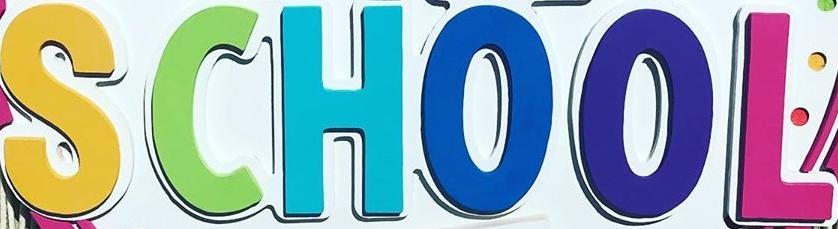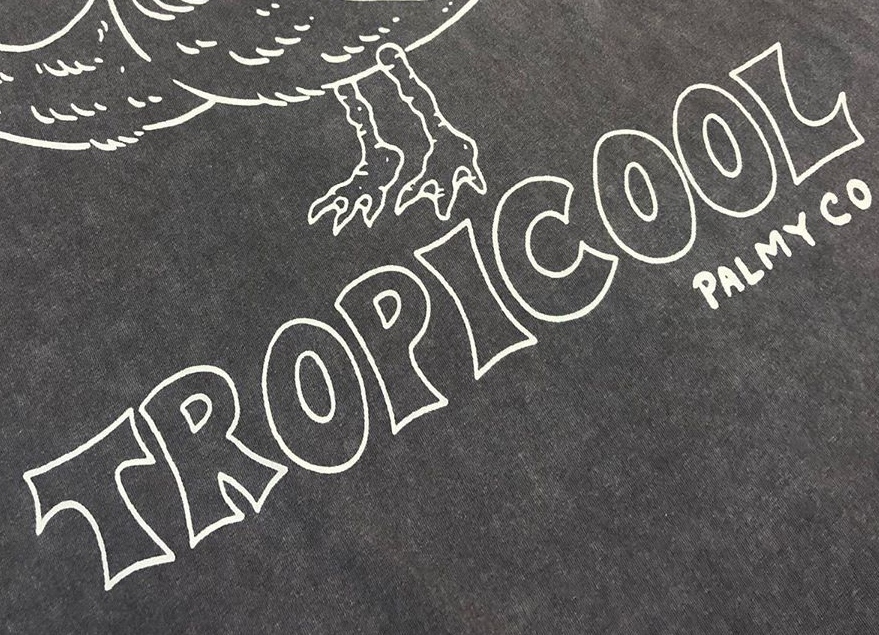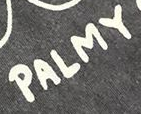What words are shown in these images in order, separated by a semicolon? SCHOOL; TROPICOOL; PALMY 